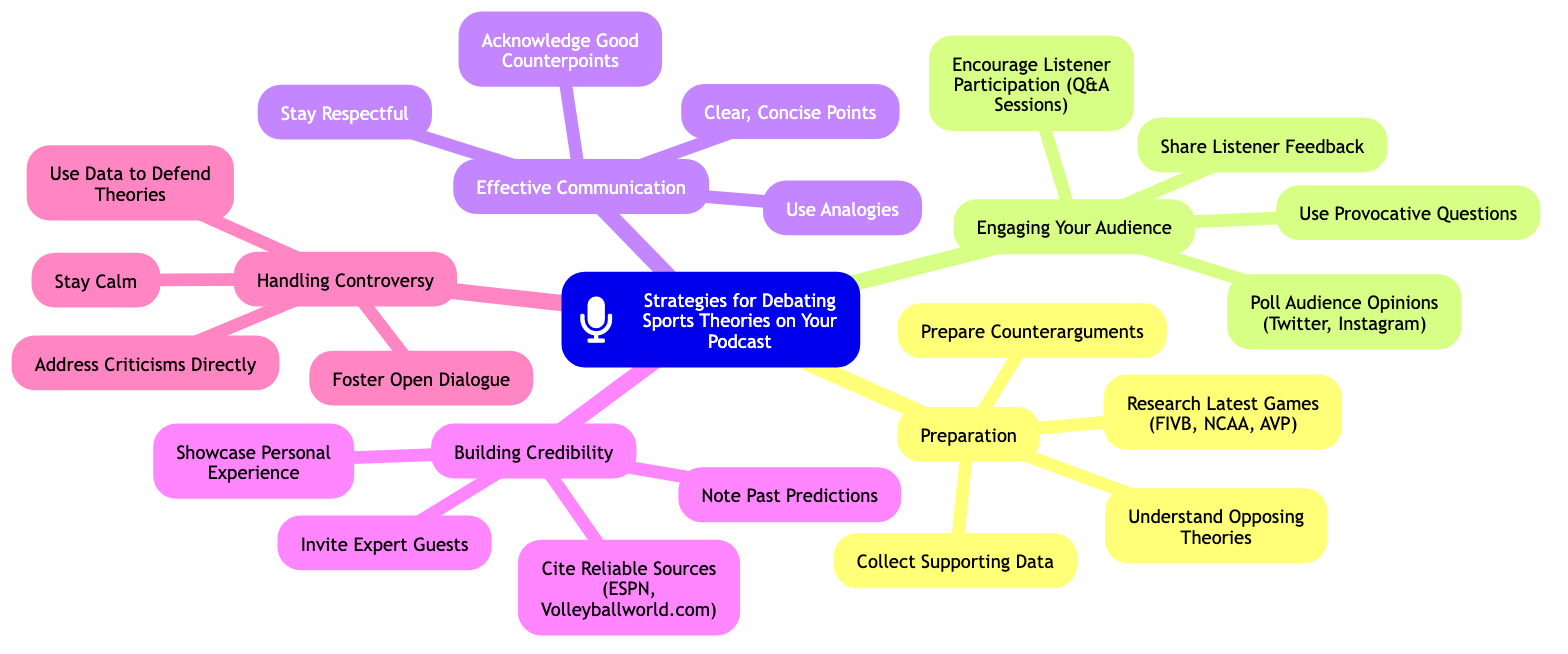What is the main topic of the mind map? The main topic is explicitly stated at the top of the mind map as "Strategies for Debating Sports Theories on Your Podcast."
Answer: Strategies for Debating Sports Theories on Your Podcast How many subtopics are there in the mind map? There are five subtopics listed in the mind map: Preparation, Engaging Your Audience, Effective Communication, Building Credibility, and Handling Controversy.
Answer: 5 Which subtopic includes "Invite Expert Guests"? "Invite Expert Guests" is listed under the subtopic "Building Credibility."
Answer: Building Credibility What does the "Engaging Your Audience" subtopic suggest for listener involvement? The subtopic "Engaging Your Audience" includes "Encourage Listener Participation (Q&A Sessions)" which suggests involving listeners actively during the podcast.
Answer: Encourage Listener Participation (Q&A Sessions) Which two strategies suggest handling criticism? The strategies under "Handling Controversy" that suggest dealing with criticism are “Address Criticisms Directly” and "Use Data to Defend Theories."
Answer: Address Criticisms Directly, Use Data to Defend Theories What is one element proposed for collecting data to support theories? Under the "Preparation" subtopic, one element proposed is "Collect Supporting Data."
Answer: Collect Supporting Data How can you acknowledge opposing views according to the mind map? The mind map suggests acknowledging opposing views through the element "Acknowledge Good Counterpoints" under the "Effective Communication" subtopic.
Answer: Acknowledge Good Counterpoints What is the recommended approach to discussions on controversial topics? The approach recommended is to "Stay Calm" as highlighted in the "Handling Controversy" subtopic.
Answer: Stay Calm 